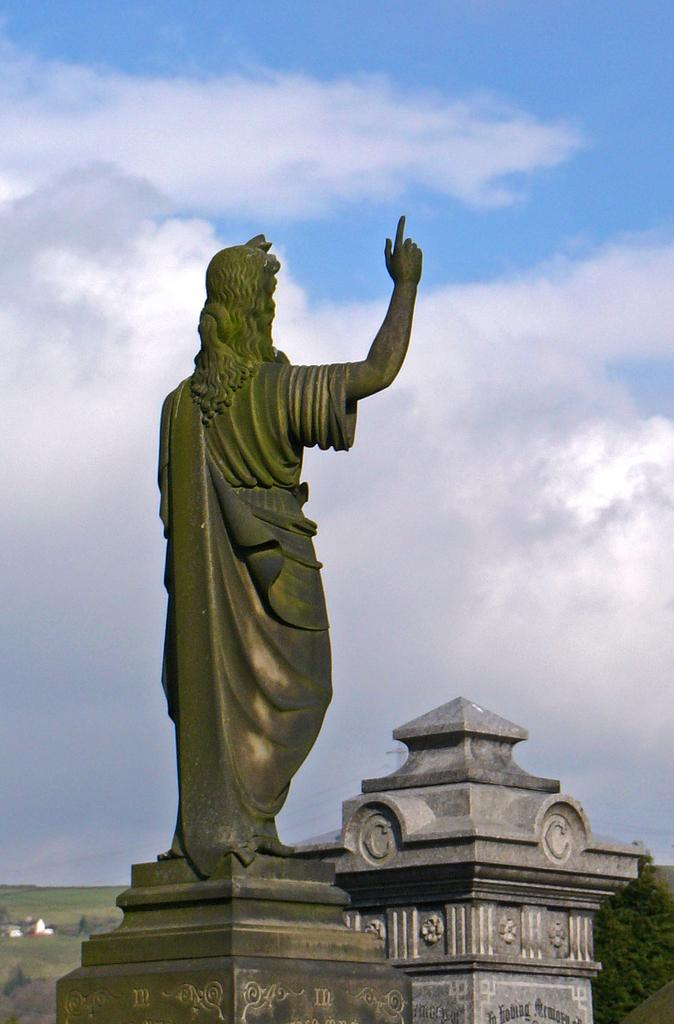What is the main subject in the image? There is a statue of a person standing in the image. What other objects or features can be seen in the image? There is a memorial stone and a tree in the bottom right corner of the image. What can be seen in the background of the image? The sky is visible in the background of the image. What type of cake is being served at the train station in the image? There is no cake or train station present in the image; it features a statue, a memorial stone, a tree, and the sky. 